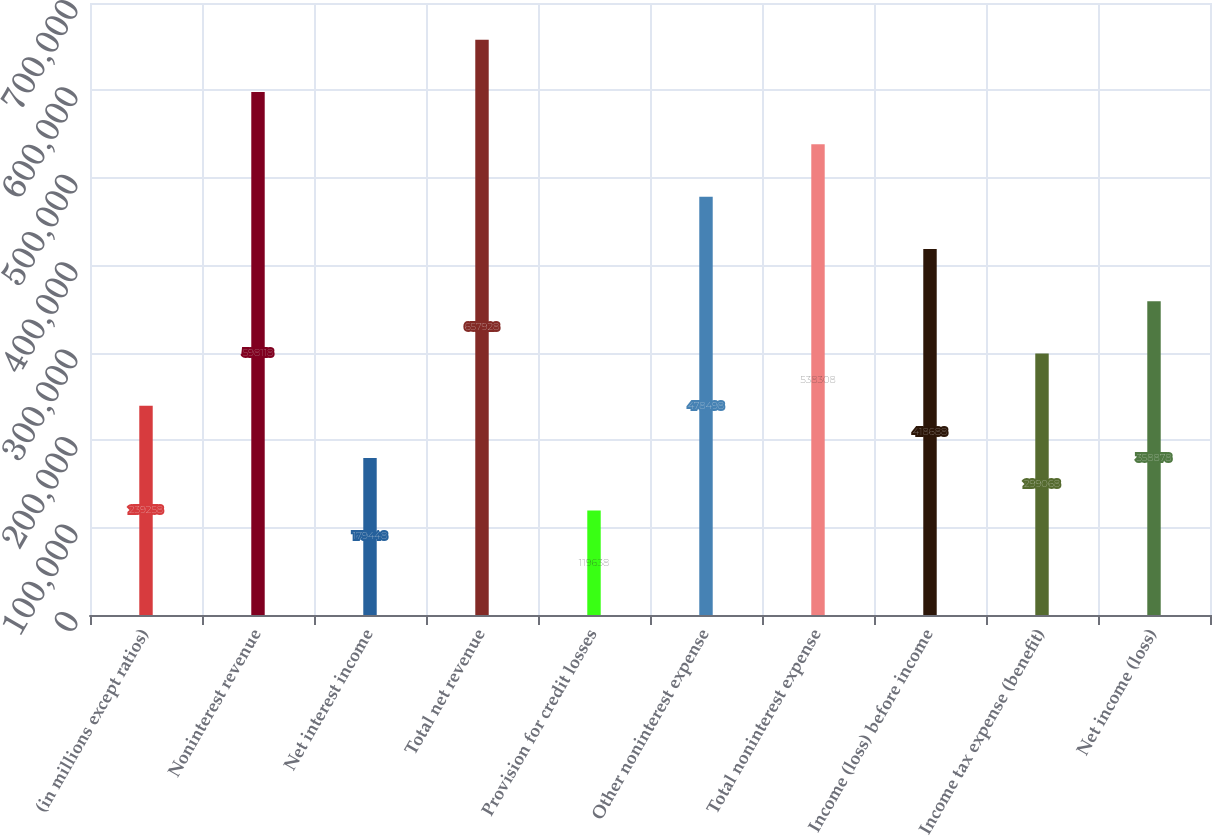Convert chart to OTSL. <chart><loc_0><loc_0><loc_500><loc_500><bar_chart><fcel>(in millions except ratios)<fcel>Noninterest revenue<fcel>Net interest income<fcel>Total net revenue<fcel>Provision for credit losses<fcel>Other noninterest expense<fcel>Total noninterest expense<fcel>Income (loss) before income<fcel>Income tax expense (benefit)<fcel>Net income (loss)<nl><fcel>239258<fcel>598118<fcel>179448<fcel>657928<fcel>119638<fcel>478498<fcel>538308<fcel>418688<fcel>299068<fcel>358878<nl></chart> 